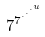<formula> <loc_0><loc_0><loc_500><loc_500>7 ^ { 7 ^ { \cdot ^ { \cdot ^ { \cdot ^ { u } } } } }</formula> 